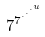<formula> <loc_0><loc_0><loc_500><loc_500>7 ^ { 7 ^ { \cdot ^ { \cdot ^ { \cdot ^ { u } } } } }</formula> 